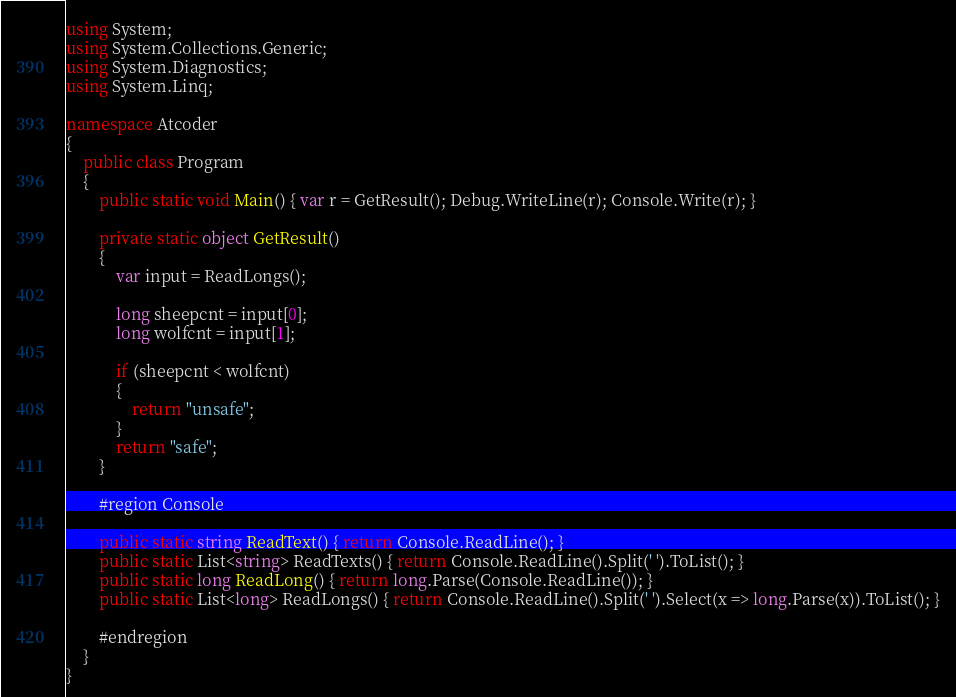Convert code to text. <code><loc_0><loc_0><loc_500><loc_500><_C#_>using System;
using System.Collections.Generic;
using System.Diagnostics;
using System.Linq;

namespace Atcoder
{
    public class Program
    {
        public static void Main() { var r = GetResult(); Debug.WriteLine(r); Console.Write(r); }

        private static object GetResult()
        {
            var input = ReadLongs();

            long sheepcnt = input[0];
            long wolfcnt = input[1];

            if (sheepcnt < wolfcnt)
            {
                return "unsafe";
            }
            return "safe";
        }

        #region Console

        public static string ReadText() { return Console.ReadLine(); }
        public static List<string> ReadTexts() { return Console.ReadLine().Split(' ').ToList(); }
        public static long ReadLong() { return long.Parse(Console.ReadLine()); }
        public static List<long> ReadLongs() { return Console.ReadLine().Split(' ').Select(x => long.Parse(x)).ToList(); }

        #endregion
    }
}

</code> 